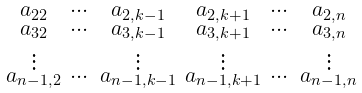Convert formula to latex. <formula><loc_0><loc_0><loc_500><loc_500>\begin{smallmatrix} a _ { 2 2 } & \cdots & a _ { 2 , k - 1 } & a _ { 2 , k + 1 } & \cdots & a _ { 2 , n } \\ a _ { 3 2 } & \cdots & a _ { 3 , k - 1 } & a _ { 3 , k + 1 } & \cdots & a _ { 3 , n } \\ \vdots & & \vdots & \vdots & & \vdots \\ a _ { n - 1 , 2 } & \cdots & a _ { n - 1 , k - 1 } & a _ { n - 1 , k + 1 } & \cdots & a _ { n - 1 , n } \\ \end{smallmatrix}</formula> 